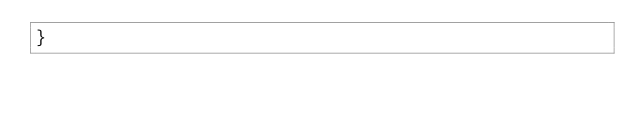Convert code to text. <code><loc_0><loc_0><loc_500><loc_500><_JavaScript_>}
</code> 